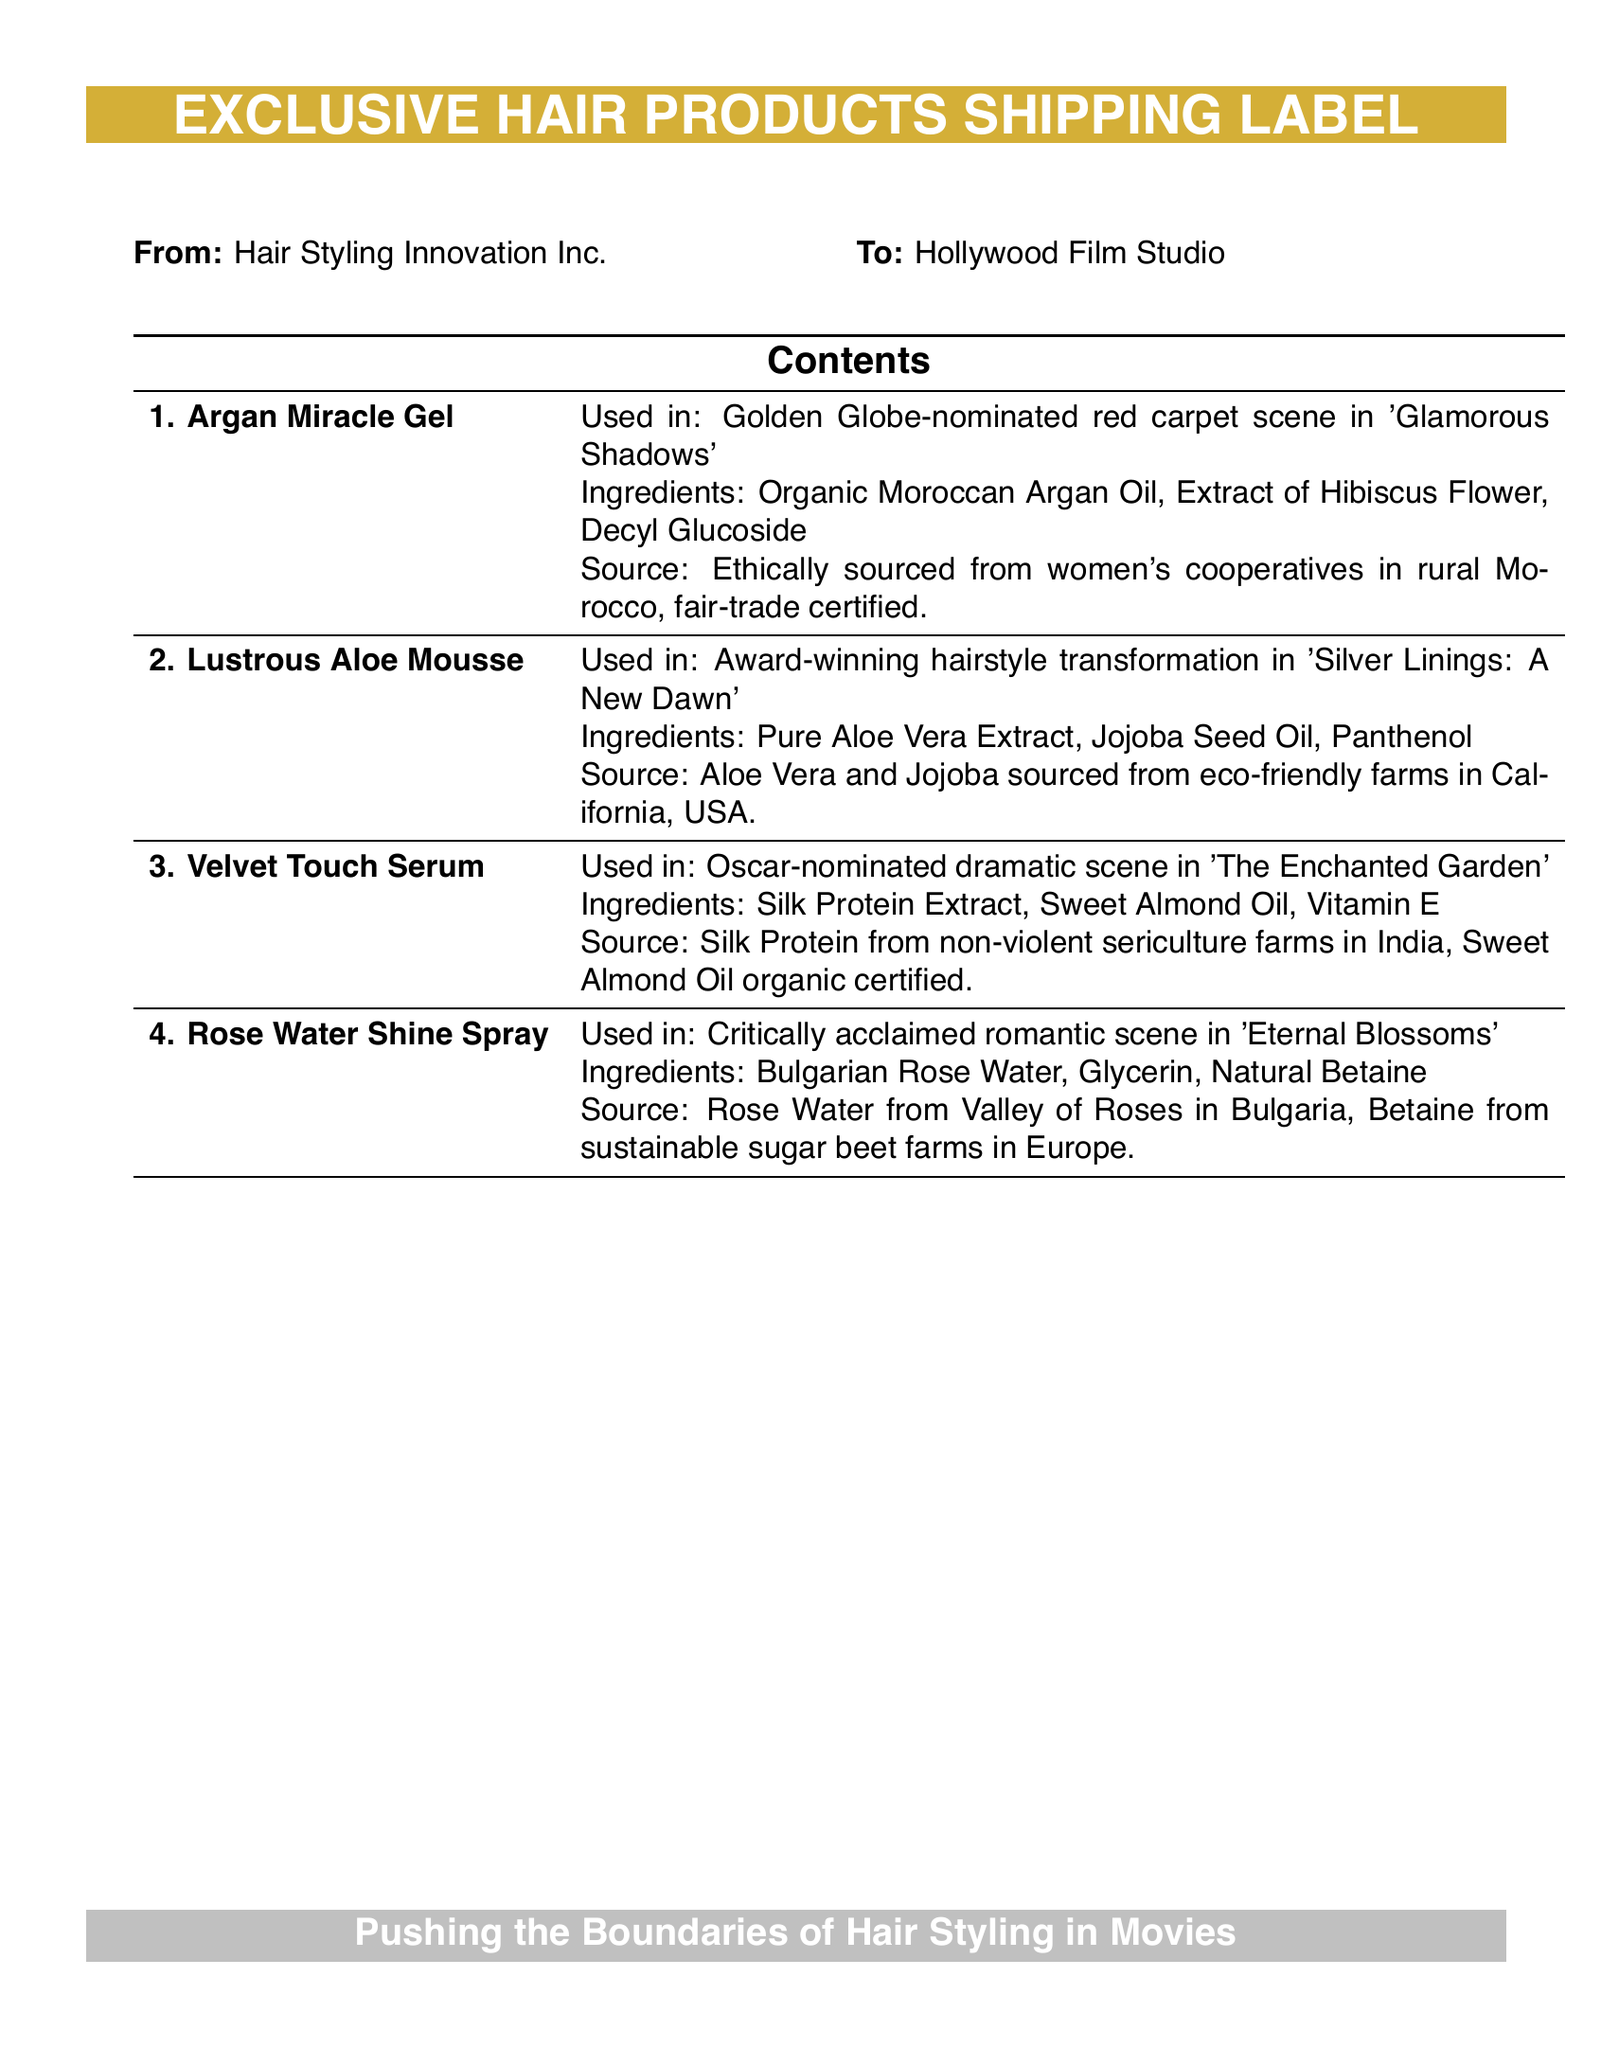What is the company sending the products? The document indicates that Hair Styling Innovation Inc. is the sender of the exclusive hair products.
Answer: Hair Styling Innovation Inc What is the destination of the shipping label? The shipping label specifies that the products are being sent to the Hollywood Film Studio.
Answer: Hollywood Film Studio Which product contains Argan Oil? The label mentions that Argan Miracle Gel is the product that contains Organic Moroccan Argan Oil.
Answer: Argan Miracle Gel What is a key ingredient in the Lustrous Aloe Mousse? Lustrous Aloe Mousse includes Pure Aloe Vera Extract as one of its main ingredients.
Answer: Pure Aloe Vera Extract Where is the source of the Silk Protein for Velvet Touch Serum? The document states that the Silk Protein is derived from non-violent sericulture farms in India.
Answer: India Which movie features the Rose Water Shine Spray? The shipping label notes that Rose Water Shine Spray is used in the critically acclaimed romantic scene of 'Eternal Blossoms'.
Answer: Eternal Blossoms What type of farms are mentioned for sourcing Jojoba? The label indicates that Jojoba is sourced from eco-friendly farms located in California, USA.
Answer: Eco-friendly farms in California What unique sourcing aspect is highlighted for the Argan Miracle Gel? The label notes that the Argan Miracle Gel ingredients are ethically sourced from women's cooperatives in rural Morocco with fair-trade certification.
Answer: Ethically sourced, fair-trade certified How many products are listed in the document? By reviewing the contents of the document, it can be determined that there are four exclusive hair products listed.
Answer: Four 